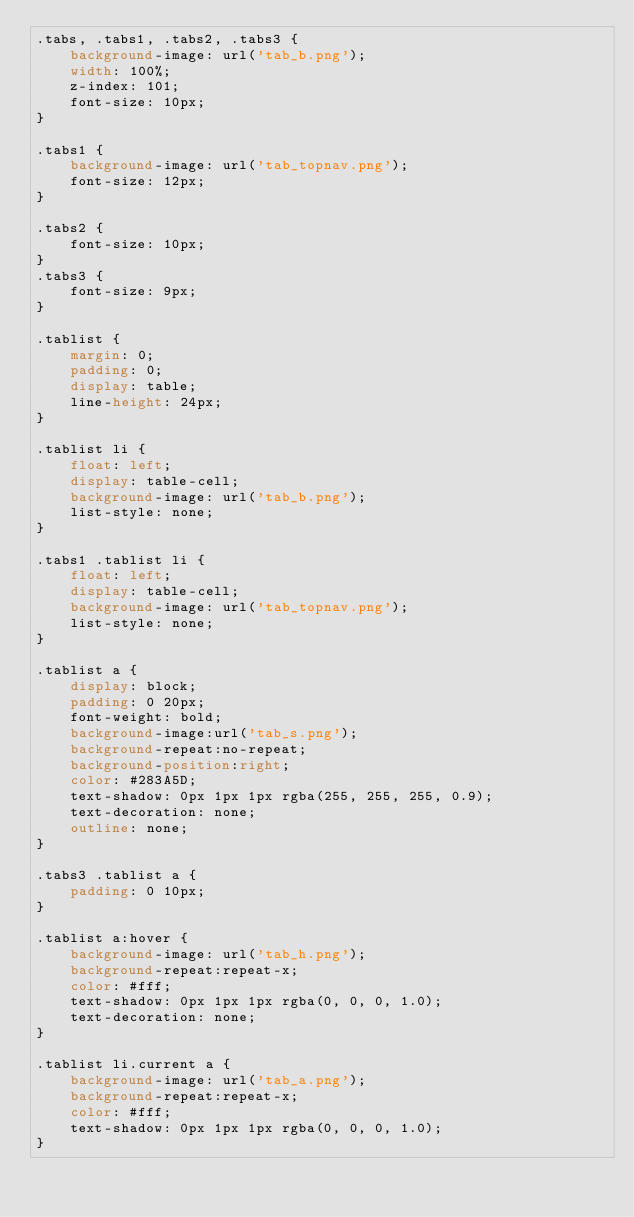Convert code to text. <code><loc_0><loc_0><loc_500><loc_500><_CSS_>.tabs, .tabs1, .tabs2, .tabs3 {
    background-image: url('tab_b.png');
    width: 100%;
    z-index: 101;
    font-size: 10px;
}

.tabs1 {
    background-image: url('tab_topnav.png');
    font-size: 12px;
}

.tabs2 {
    font-size: 10px;
}
.tabs3 {
    font-size: 9px;
}

.tablist {
    margin: 0;
    padding: 0;
    display: table;
    line-height: 24px;
}

.tablist li {
    float: left;
    display: table-cell;
    background-image: url('tab_b.png');
    list-style: none;
}

.tabs1 .tablist li {
    float: left;
    display: table-cell;
    background-image: url('tab_topnav.png');
    list-style: none;
}

.tablist a {
    display: block;
    padding: 0 20px;
    font-weight: bold;
    background-image:url('tab_s.png');
    background-repeat:no-repeat;
    background-position:right;
    color: #283A5D;
    text-shadow: 0px 1px 1px rgba(255, 255, 255, 0.9);
    text-decoration: none;
    outline: none;
}

.tabs3 .tablist a {
    padding: 0 10px;
}

.tablist a:hover {
    background-image: url('tab_h.png');
    background-repeat:repeat-x;
    color: #fff;
    text-shadow: 0px 1px 1px rgba(0, 0, 0, 1.0);
    text-decoration: none;
}

.tablist li.current a {
    background-image: url('tab_a.png');
    background-repeat:repeat-x;
    color: #fff;
    text-shadow: 0px 1px 1px rgba(0, 0, 0, 1.0);
}
</code> 